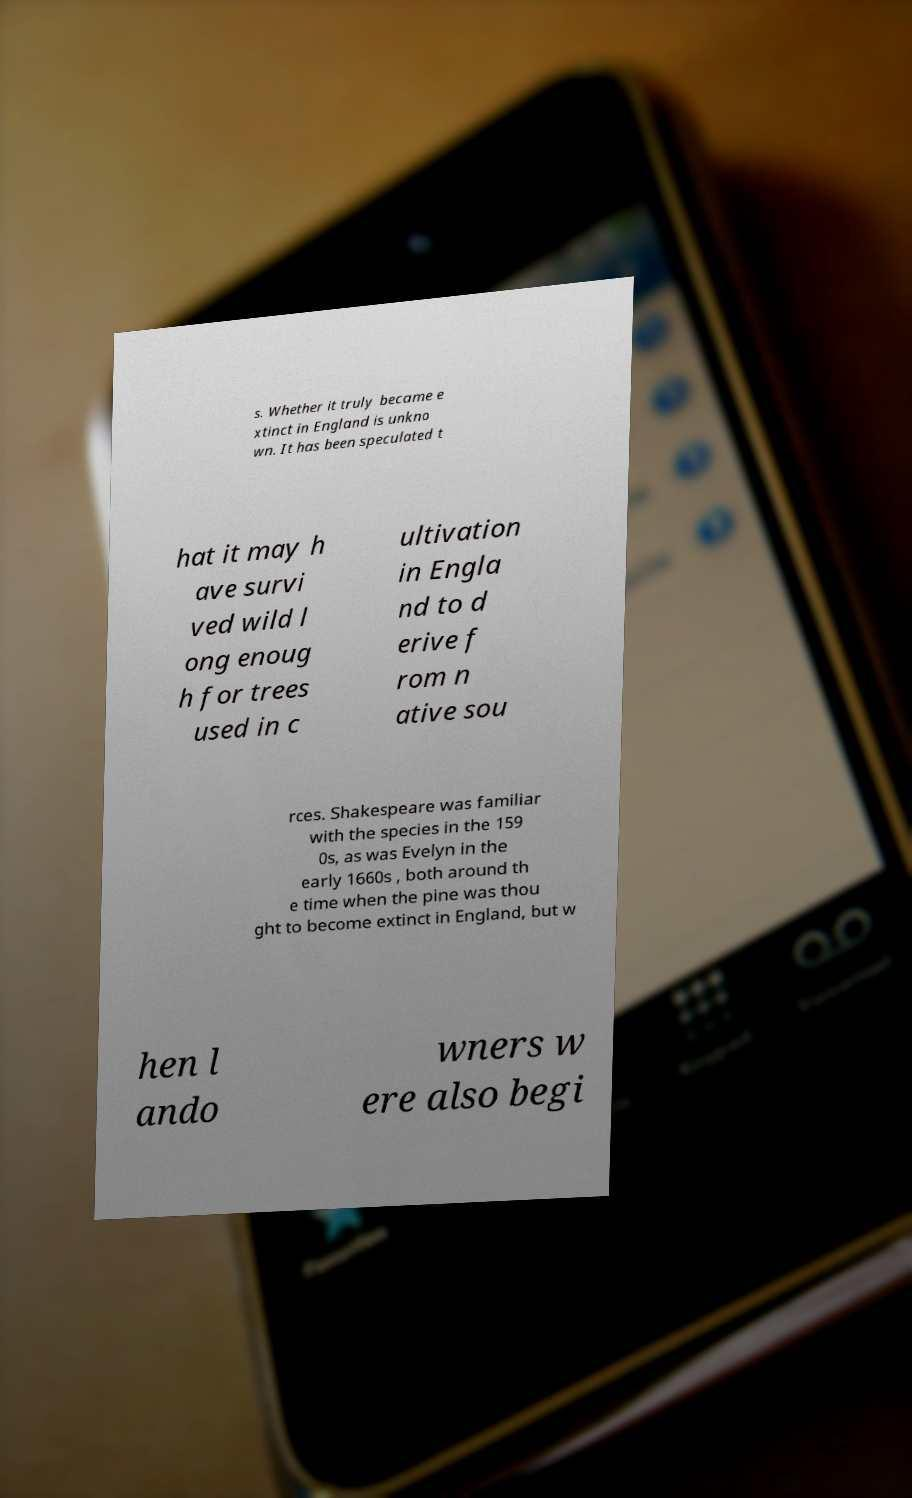For documentation purposes, I need the text within this image transcribed. Could you provide that? s. Whether it truly became e xtinct in England is unkno wn. It has been speculated t hat it may h ave survi ved wild l ong enoug h for trees used in c ultivation in Engla nd to d erive f rom n ative sou rces. Shakespeare was familiar with the species in the 159 0s, as was Evelyn in the early 1660s , both around th e time when the pine was thou ght to become extinct in England, but w hen l ando wners w ere also begi 